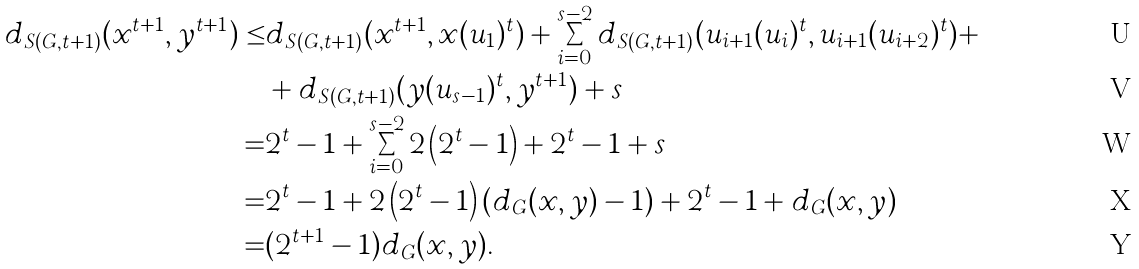Convert formula to latex. <formula><loc_0><loc_0><loc_500><loc_500>d _ { S ( G , t + 1 ) } ( x ^ { t + 1 } , y ^ { t + 1 } ) \leq & d _ { S ( G , t + 1 ) } ( x ^ { t + 1 } , x ( u _ { 1 } ) ^ { t } ) + \sum _ { i = 0 } ^ { s - 2 } d _ { S ( G , t + 1 ) } ( u _ { i + 1 } ( u _ { i } ) ^ { t } , u _ { i + 1 } ( u _ { i + 2 } ) ^ { t } ) + \\ & + d _ { S ( G , t + 1 ) } ( y ( u _ { s - 1 } ) ^ { t } , y ^ { t + 1 } ) + s \\ = & 2 ^ { t } - 1 + \sum _ { i = 0 } ^ { s - 2 } 2 \left ( 2 ^ { t } - 1 \right ) + 2 ^ { t } - 1 + s \\ = & 2 ^ { t } - 1 + 2 \left ( 2 ^ { t } - 1 \right ) ( d _ { G } ( x , y ) - 1 ) + 2 ^ { t } - 1 + d _ { G } ( x , y ) \\ = & ( 2 ^ { t + 1 } - 1 ) d _ { G } ( x , y ) .</formula> 